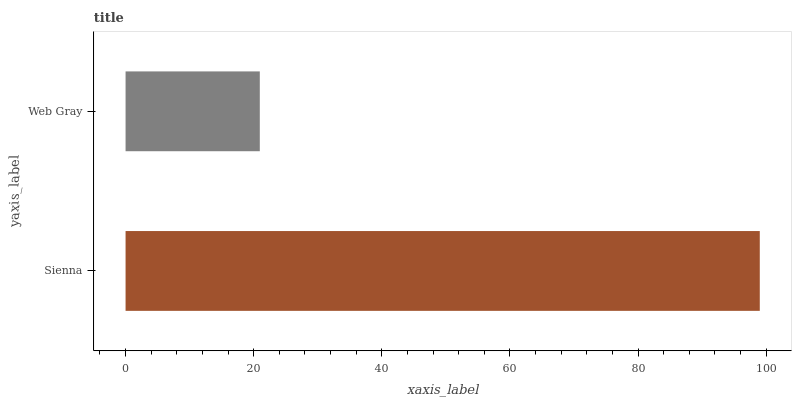Is Web Gray the minimum?
Answer yes or no. Yes. Is Sienna the maximum?
Answer yes or no. Yes. Is Web Gray the maximum?
Answer yes or no. No. Is Sienna greater than Web Gray?
Answer yes or no. Yes. Is Web Gray less than Sienna?
Answer yes or no. Yes. Is Web Gray greater than Sienna?
Answer yes or no. No. Is Sienna less than Web Gray?
Answer yes or no. No. Is Sienna the high median?
Answer yes or no. Yes. Is Web Gray the low median?
Answer yes or no. Yes. Is Web Gray the high median?
Answer yes or no. No. Is Sienna the low median?
Answer yes or no. No. 